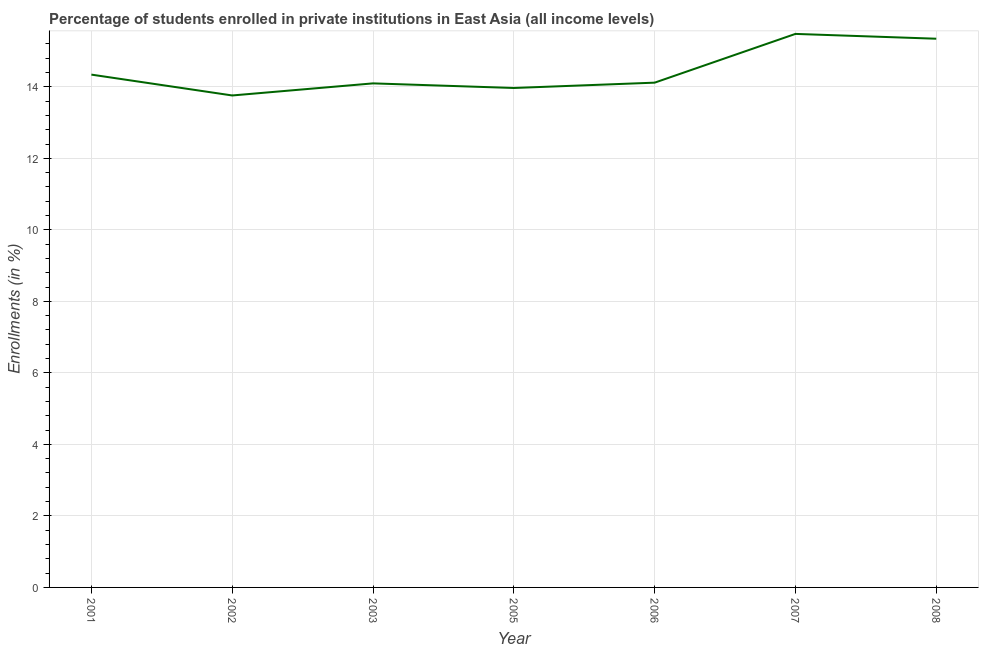What is the enrollments in private institutions in 2006?
Provide a succinct answer. 14.12. Across all years, what is the maximum enrollments in private institutions?
Your response must be concise. 15.48. Across all years, what is the minimum enrollments in private institutions?
Make the answer very short. 13.76. In which year was the enrollments in private institutions maximum?
Ensure brevity in your answer.  2007. What is the sum of the enrollments in private institutions?
Keep it short and to the point. 101.1. What is the difference between the enrollments in private institutions in 2003 and 2005?
Offer a very short reply. 0.13. What is the average enrollments in private institutions per year?
Your answer should be very brief. 14.44. What is the median enrollments in private institutions?
Offer a terse response. 14.12. What is the ratio of the enrollments in private institutions in 2003 to that in 2007?
Offer a terse response. 0.91. Is the enrollments in private institutions in 2007 less than that in 2008?
Give a very brief answer. No. What is the difference between the highest and the second highest enrollments in private institutions?
Offer a terse response. 0.13. What is the difference between the highest and the lowest enrollments in private institutions?
Make the answer very short. 1.72. In how many years, is the enrollments in private institutions greater than the average enrollments in private institutions taken over all years?
Your response must be concise. 2. Are the values on the major ticks of Y-axis written in scientific E-notation?
Provide a short and direct response. No. What is the title of the graph?
Your answer should be compact. Percentage of students enrolled in private institutions in East Asia (all income levels). What is the label or title of the X-axis?
Offer a terse response. Year. What is the label or title of the Y-axis?
Provide a short and direct response. Enrollments (in %). What is the Enrollments (in %) in 2001?
Your response must be concise. 14.34. What is the Enrollments (in %) in 2002?
Keep it short and to the point. 13.76. What is the Enrollments (in %) in 2003?
Offer a very short reply. 14.1. What is the Enrollments (in %) in 2005?
Your answer should be very brief. 13.97. What is the Enrollments (in %) in 2006?
Provide a short and direct response. 14.12. What is the Enrollments (in %) of 2007?
Provide a succinct answer. 15.48. What is the Enrollments (in %) of 2008?
Your answer should be very brief. 15.34. What is the difference between the Enrollments (in %) in 2001 and 2002?
Keep it short and to the point. 0.58. What is the difference between the Enrollments (in %) in 2001 and 2003?
Keep it short and to the point. 0.24. What is the difference between the Enrollments (in %) in 2001 and 2005?
Ensure brevity in your answer.  0.37. What is the difference between the Enrollments (in %) in 2001 and 2006?
Offer a terse response. 0.22. What is the difference between the Enrollments (in %) in 2001 and 2007?
Provide a short and direct response. -1.14. What is the difference between the Enrollments (in %) in 2001 and 2008?
Your response must be concise. -1. What is the difference between the Enrollments (in %) in 2002 and 2003?
Offer a very short reply. -0.34. What is the difference between the Enrollments (in %) in 2002 and 2005?
Provide a short and direct response. -0.21. What is the difference between the Enrollments (in %) in 2002 and 2006?
Make the answer very short. -0.36. What is the difference between the Enrollments (in %) in 2002 and 2007?
Provide a short and direct response. -1.72. What is the difference between the Enrollments (in %) in 2002 and 2008?
Offer a very short reply. -1.59. What is the difference between the Enrollments (in %) in 2003 and 2005?
Offer a terse response. 0.13. What is the difference between the Enrollments (in %) in 2003 and 2006?
Offer a terse response. -0.02. What is the difference between the Enrollments (in %) in 2003 and 2007?
Your answer should be compact. -1.38. What is the difference between the Enrollments (in %) in 2003 and 2008?
Your answer should be very brief. -1.25. What is the difference between the Enrollments (in %) in 2005 and 2006?
Ensure brevity in your answer.  -0.15. What is the difference between the Enrollments (in %) in 2005 and 2007?
Ensure brevity in your answer.  -1.51. What is the difference between the Enrollments (in %) in 2005 and 2008?
Offer a terse response. -1.38. What is the difference between the Enrollments (in %) in 2006 and 2007?
Offer a very short reply. -1.36. What is the difference between the Enrollments (in %) in 2006 and 2008?
Offer a terse response. -1.23. What is the difference between the Enrollments (in %) in 2007 and 2008?
Your response must be concise. 0.13. What is the ratio of the Enrollments (in %) in 2001 to that in 2002?
Give a very brief answer. 1.04. What is the ratio of the Enrollments (in %) in 2001 to that in 2003?
Provide a succinct answer. 1.02. What is the ratio of the Enrollments (in %) in 2001 to that in 2005?
Your answer should be very brief. 1.03. What is the ratio of the Enrollments (in %) in 2001 to that in 2006?
Your answer should be very brief. 1.02. What is the ratio of the Enrollments (in %) in 2001 to that in 2007?
Your answer should be very brief. 0.93. What is the ratio of the Enrollments (in %) in 2001 to that in 2008?
Your response must be concise. 0.94. What is the ratio of the Enrollments (in %) in 2002 to that in 2003?
Give a very brief answer. 0.98. What is the ratio of the Enrollments (in %) in 2002 to that in 2006?
Your answer should be very brief. 0.97. What is the ratio of the Enrollments (in %) in 2002 to that in 2007?
Offer a terse response. 0.89. What is the ratio of the Enrollments (in %) in 2002 to that in 2008?
Provide a succinct answer. 0.9. What is the ratio of the Enrollments (in %) in 2003 to that in 2005?
Keep it short and to the point. 1.01. What is the ratio of the Enrollments (in %) in 2003 to that in 2007?
Your answer should be very brief. 0.91. What is the ratio of the Enrollments (in %) in 2003 to that in 2008?
Give a very brief answer. 0.92. What is the ratio of the Enrollments (in %) in 2005 to that in 2006?
Give a very brief answer. 0.99. What is the ratio of the Enrollments (in %) in 2005 to that in 2007?
Your answer should be compact. 0.9. What is the ratio of the Enrollments (in %) in 2005 to that in 2008?
Provide a succinct answer. 0.91. What is the ratio of the Enrollments (in %) in 2006 to that in 2007?
Ensure brevity in your answer.  0.91. What is the ratio of the Enrollments (in %) in 2006 to that in 2008?
Provide a succinct answer. 0.92. 